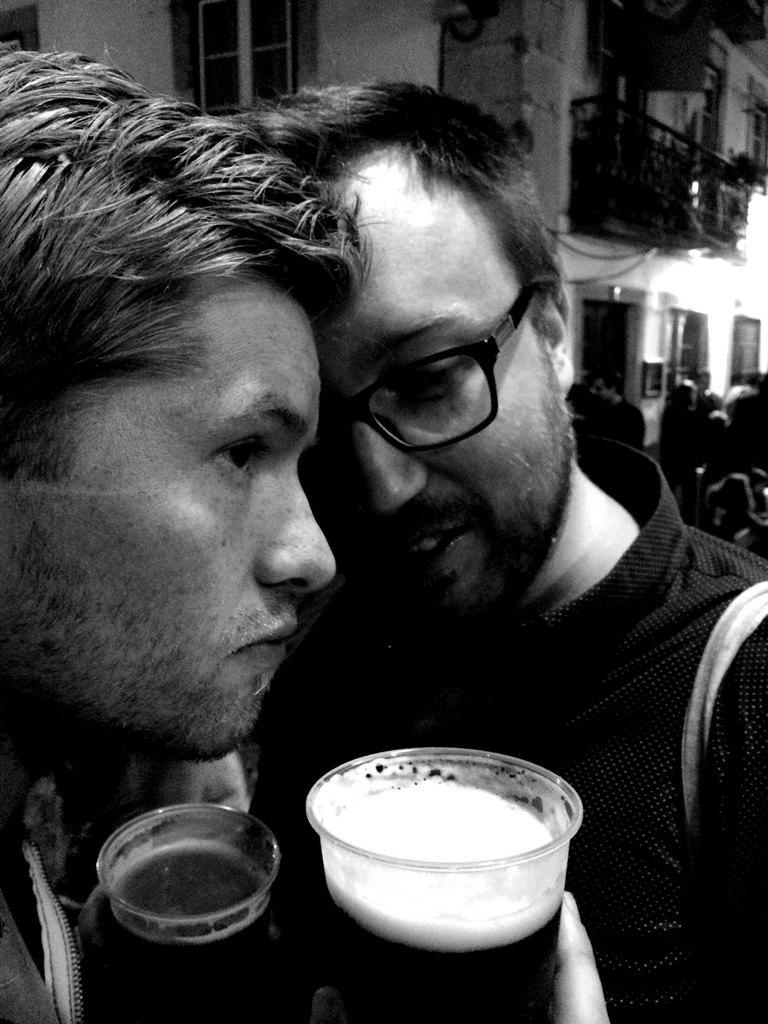What is the main subject of the image? The main subject of the image is two boys in the center. What are the boys holding in their hands? The boys are holding glasses in their hands. Are there any other people visible in the image? Yes, there are other people on the right side of the image. What type of roof can be seen on the grass in the image? There is no roof or grass present in the image; it features two boys holding glasses and other people on the right side. 